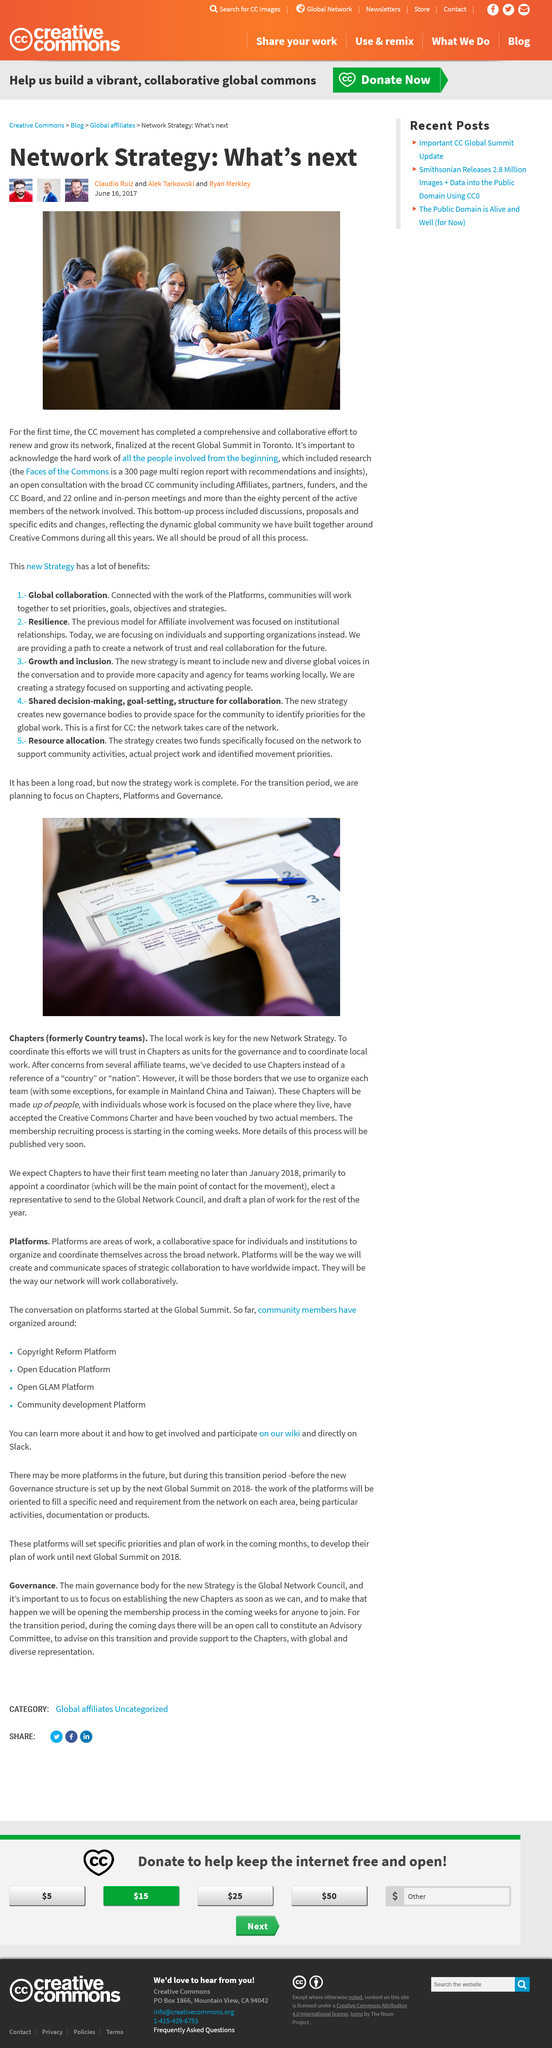List a handful of essential elements in this visual. The recent Global Summit took place in Toronto. Claudio Ruiz wrote an article about Creative Commons. The article was written on June 16, 2017. 